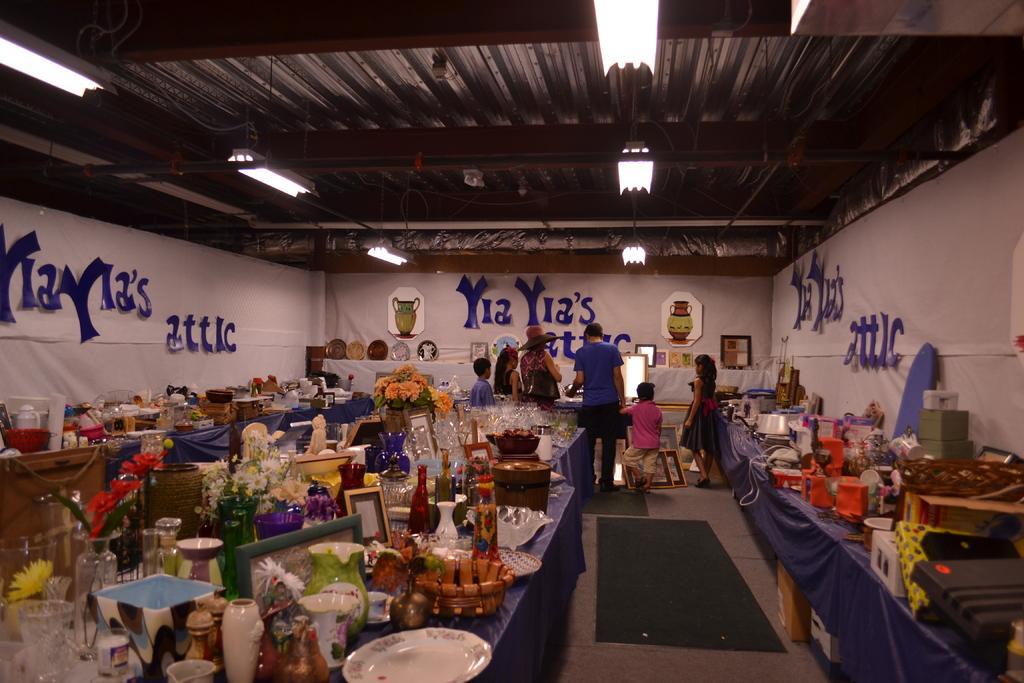Could you give a brief overview of what you see in this image? At the bottom of the image there are some tables, on the tables there are some products and bottles and flower vases. In the middle of the image few people are standing and watching. In front of them there is wall, on the wall there are some posters. At the top of the image there is roof and lights. 